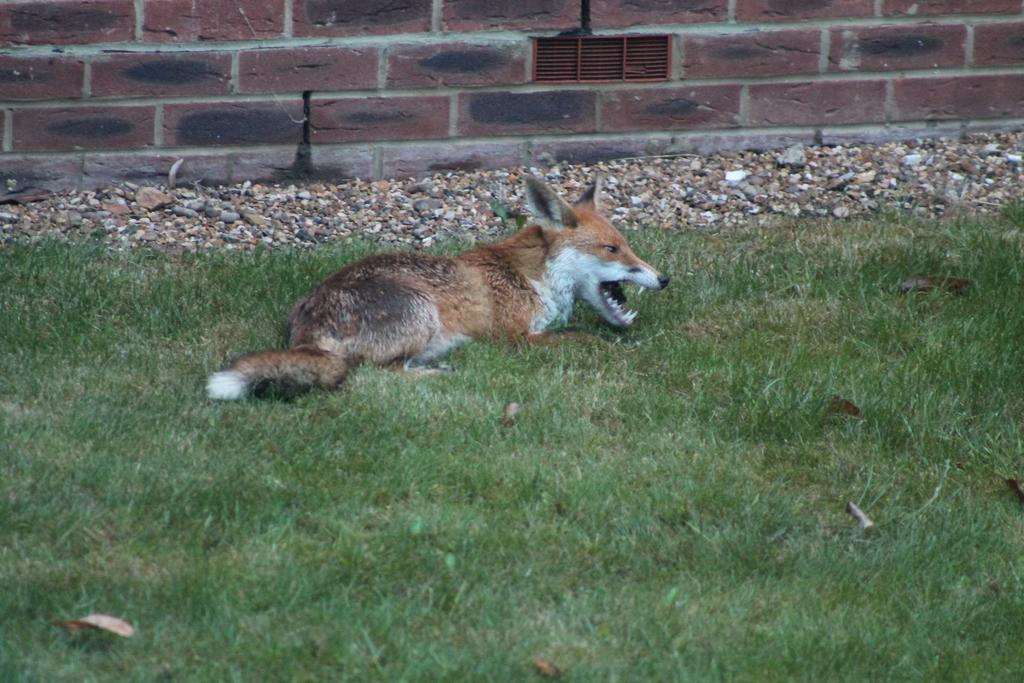What type of vegetation is in the foreground of the image? There is grass in the foreground of the image. What animal can be seen in the middle of the image? There is a dog lying on the grass in the middle of the image. What other objects are present in the middle of the image? There are stones in the middle of the image. What structure is visible at the top of the image? There is a wall visible at the top of the image. How much jam is on the dog's paw in the image? There is no jam present in the image, and the dog's paw is not mentioned in the provided facts. 